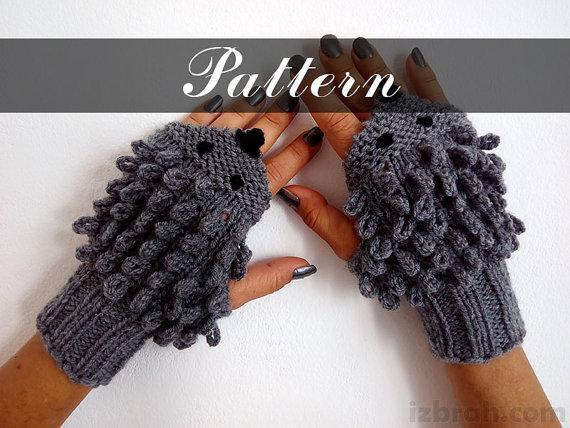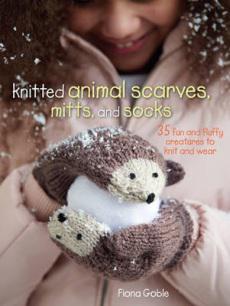The first image is the image on the left, the second image is the image on the right. Evaluate the accuracy of this statement regarding the images: "human hands are visible". Is it true? Answer yes or no. Yes. 